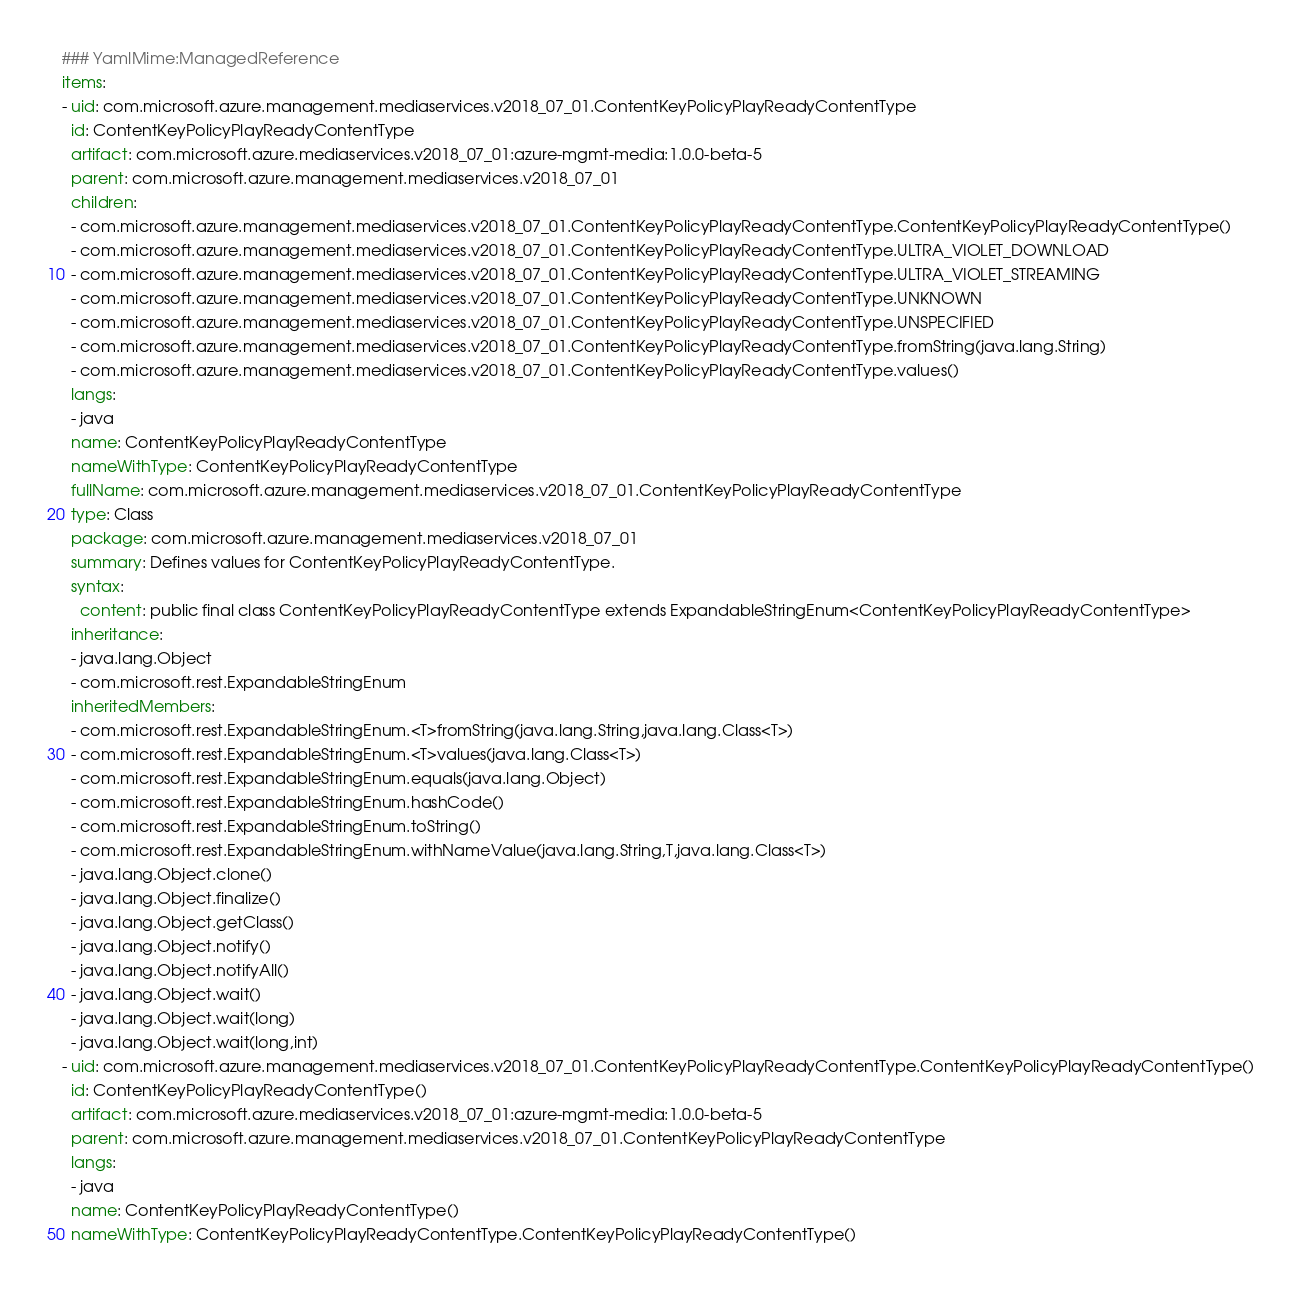Convert code to text. <code><loc_0><loc_0><loc_500><loc_500><_YAML_>### YamlMime:ManagedReference
items:
- uid: com.microsoft.azure.management.mediaservices.v2018_07_01.ContentKeyPolicyPlayReadyContentType
  id: ContentKeyPolicyPlayReadyContentType
  artifact: com.microsoft.azure.mediaservices.v2018_07_01:azure-mgmt-media:1.0.0-beta-5
  parent: com.microsoft.azure.management.mediaservices.v2018_07_01
  children:
  - com.microsoft.azure.management.mediaservices.v2018_07_01.ContentKeyPolicyPlayReadyContentType.ContentKeyPolicyPlayReadyContentType()
  - com.microsoft.azure.management.mediaservices.v2018_07_01.ContentKeyPolicyPlayReadyContentType.ULTRA_VIOLET_DOWNLOAD
  - com.microsoft.azure.management.mediaservices.v2018_07_01.ContentKeyPolicyPlayReadyContentType.ULTRA_VIOLET_STREAMING
  - com.microsoft.azure.management.mediaservices.v2018_07_01.ContentKeyPolicyPlayReadyContentType.UNKNOWN
  - com.microsoft.azure.management.mediaservices.v2018_07_01.ContentKeyPolicyPlayReadyContentType.UNSPECIFIED
  - com.microsoft.azure.management.mediaservices.v2018_07_01.ContentKeyPolicyPlayReadyContentType.fromString(java.lang.String)
  - com.microsoft.azure.management.mediaservices.v2018_07_01.ContentKeyPolicyPlayReadyContentType.values()
  langs:
  - java
  name: ContentKeyPolicyPlayReadyContentType
  nameWithType: ContentKeyPolicyPlayReadyContentType
  fullName: com.microsoft.azure.management.mediaservices.v2018_07_01.ContentKeyPolicyPlayReadyContentType
  type: Class
  package: com.microsoft.azure.management.mediaservices.v2018_07_01
  summary: Defines values for ContentKeyPolicyPlayReadyContentType.
  syntax:
    content: public final class ContentKeyPolicyPlayReadyContentType extends ExpandableStringEnum<ContentKeyPolicyPlayReadyContentType>
  inheritance:
  - java.lang.Object
  - com.microsoft.rest.ExpandableStringEnum
  inheritedMembers:
  - com.microsoft.rest.ExpandableStringEnum.<T>fromString(java.lang.String,java.lang.Class<T>)
  - com.microsoft.rest.ExpandableStringEnum.<T>values(java.lang.Class<T>)
  - com.microsoft.rest.ExpandableStringEnum.equals(java.lang.Object)
  - com.microsoft.rest.ExpandableStringEnum.hashCode()
  - com.microsoft.rest.ExpandableStringEnum.toString()
  - com.microsoft.rest.ExpandableStringEnum.withNameValue(java.lang.String,T,java.lang.Class<T>)
  - java.lang.Object.clone()
  - java.lang.Object.finalize()
  - java.lang.Object.getClass()
  - java.lang.Object.notify()
  - java.lang.Object.notifyAll()
  - java.lang.Object.wait()
  - java.lang.Object.wait(long)
  - java.lang.Object.wait(long,int)
- uid: com.microsoft.azure.management.mediaservices.v2018_07_01.ContentKeyPolicyPlayReadyContentType.ContentKeyPolicyPlayReadyContentType()
  id: ContentKeyPolicyPlayReadyContentType()
  artifact: com.microsoft.azure.mediaservices.v2018_07_01:azure-mgmt-media:1.0.0-beta-5
  parent: com.microsoft.azure.management.mediaservices.v2018_07_01.ContentKeyPolicyPlayReadyContentType
  langs:
  - java
  name: ContentKeyPolicyPlayReadyContentType()
  nameWithType: ContentKeyPolicyPlayReadyContentType.ContentKeyPolicyPlayReadyContentType()</code> 